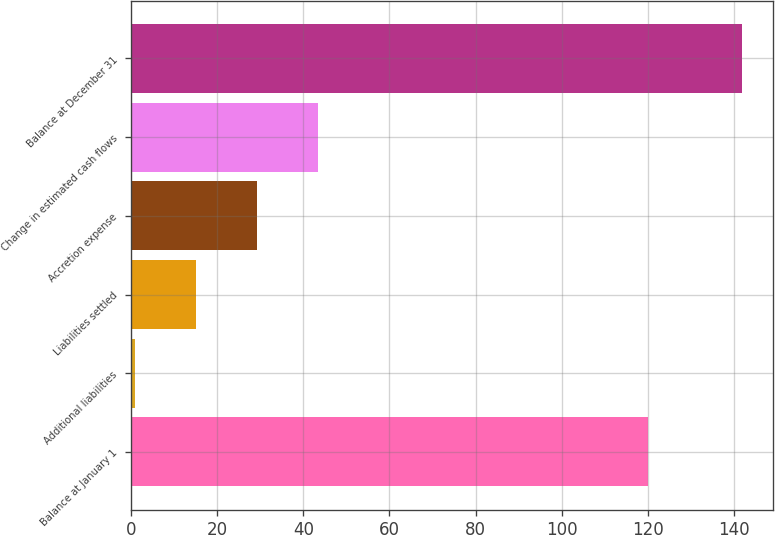Convert chart to OTSL. <chart><loc_0><loc_0><loc_500><loc_500><bar_chart><fcel>Balance at January 1<fcel>Additional liabilities<fcel>Liabilities settled<fcel>Accretion expense<fcel>Change in estimated cash flows<fcel>Balance at December 31<nl><fcel>120<fcel>1<fcel>15.1<fcel>29.2<fcel>43.3<fcel>142<nl></chart> 